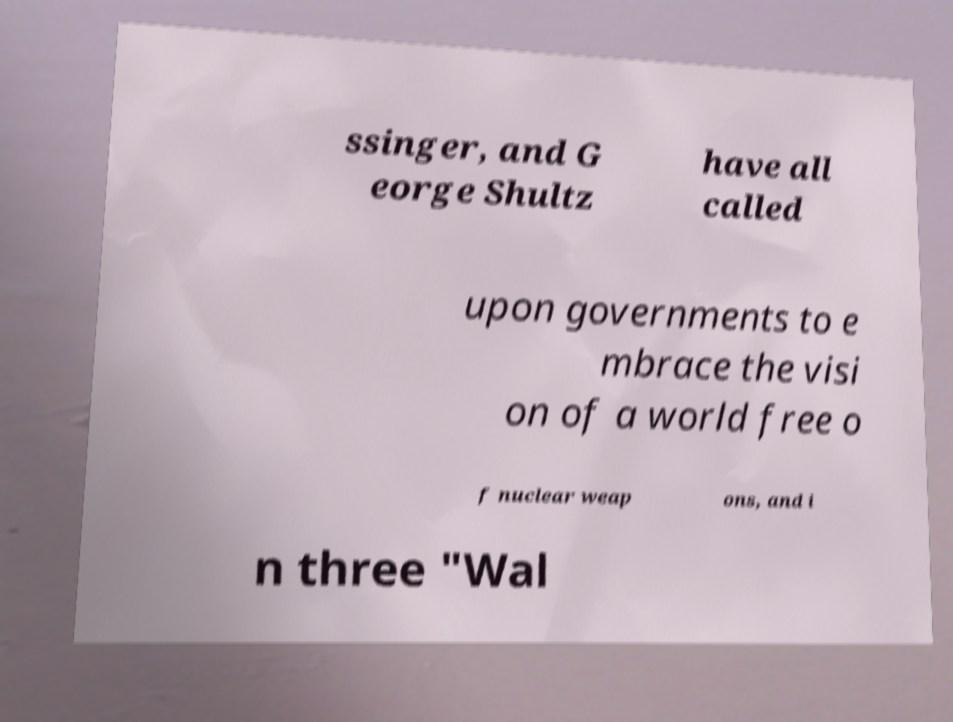Could you extract and type out the text from this image? ssinger, and G eorge Shultz have all called upon governments to e mbrace the visi on of a world free o f nuclear weap ons, and i n three "Wal 